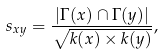Convert formula to latex. <formula><loc_0><loc_0><loc_500><loc_500>s _ { x y } = \frac { | \Gamma ( x ) \cap \Gamma ( y ) | } { \sqrt { k ( x ) \times k ( y ) } } ,</formula> 